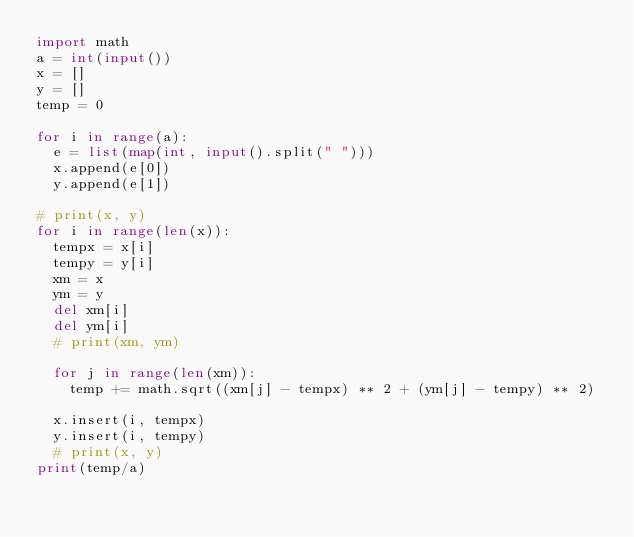Convert code to text. <code><loc_0><loc_0><loc_500><loc_500><_Python_>import math
a = int(input())
x = []
y = []
temp = 0

for i in range(a):
	e = list(map(int, input().split(" ")))
	x.append(e[0])
	y.append(e[1])

# print(x, y)
for i in range(len(x)):
	tempx = x[i]
	tempy = y[i]
	xm = x
	ym = y
	del xm[i]
	del ym[i]
	# print(xm, ym)

	for j in range(len(xm)):
		temp += math.sqrt((xm[j] - tempx) ** 2 + (ym[j] - tempy) ** 2)

	x.insert(i, tempx)
	y.insert(i, tempy)
	# print(x, y)
print(temp/a)</code> 